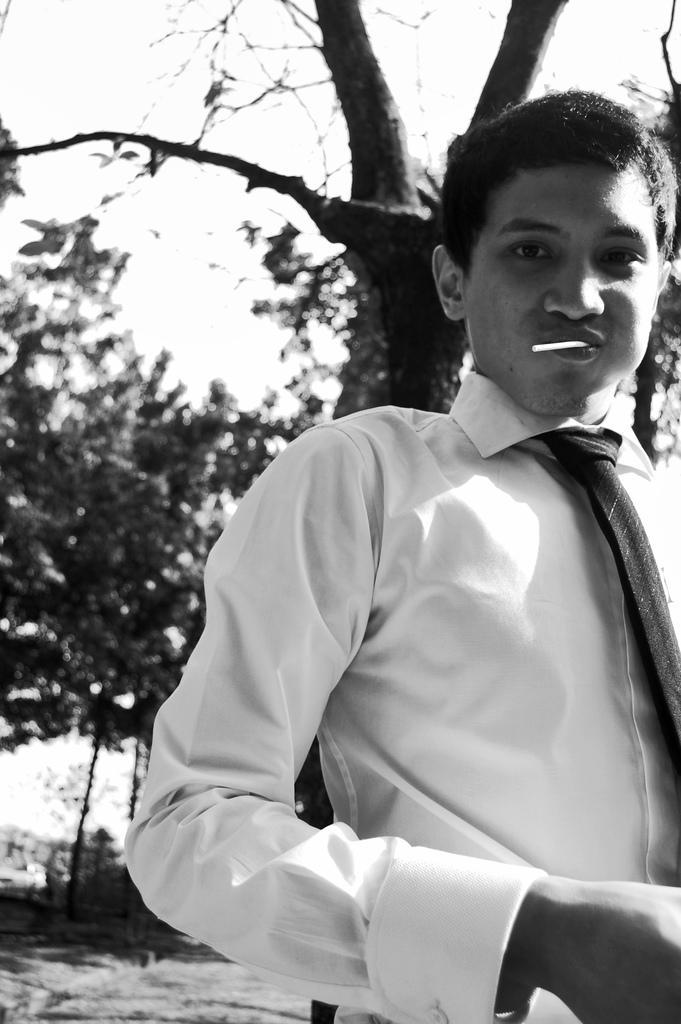Describe this image in one or two sentences. This is a black and white image. On the right side, I can see a man wearing white color shirt and looking at the picture. I can see a lollipop in his mouth. In the background there are some trees. 